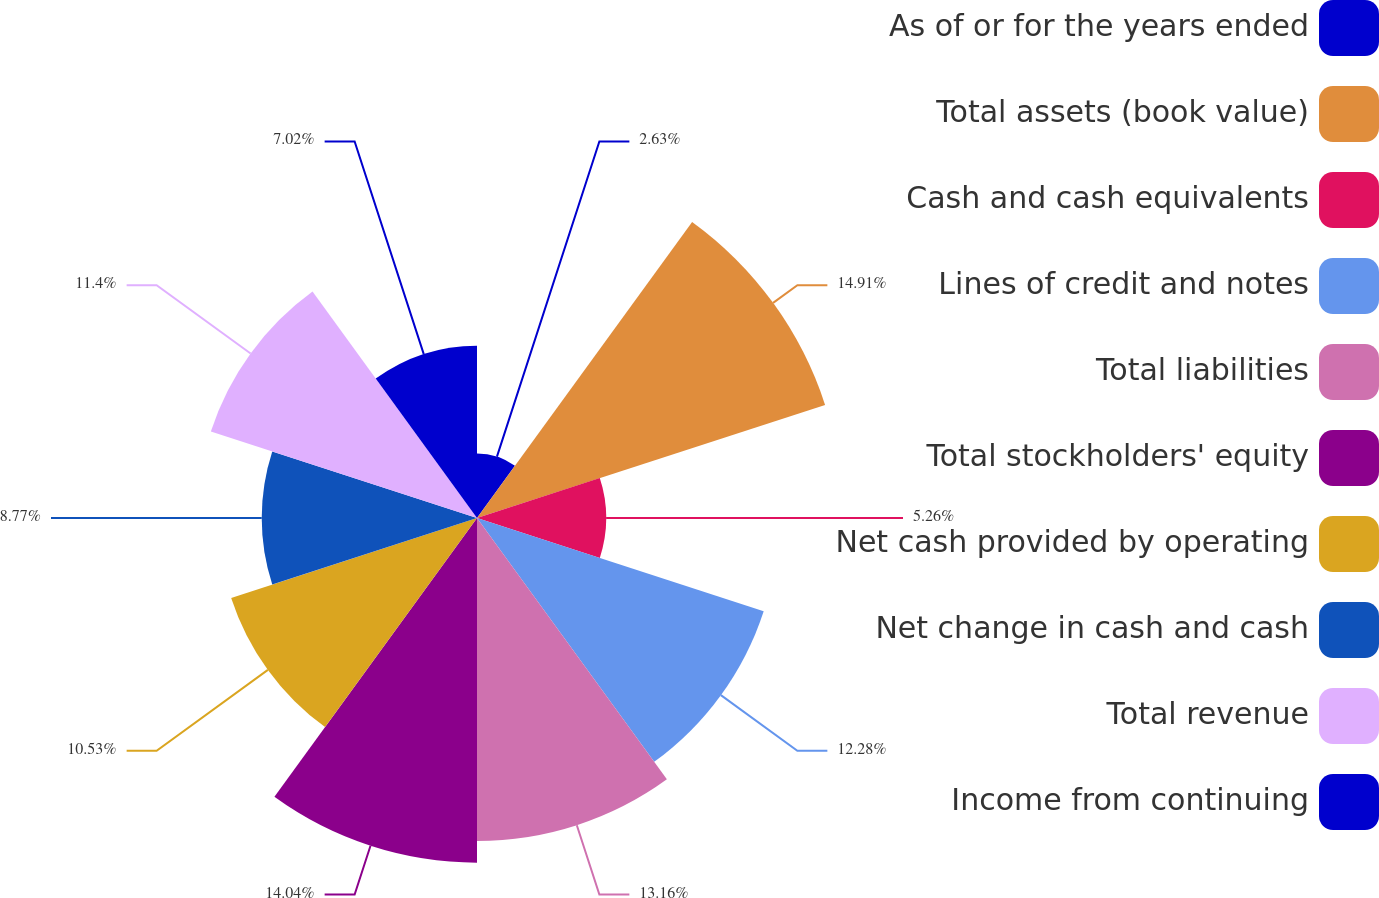Convert chart to OTSL. <chart><loc_0><loc_0><loc_500><loc_500><pie_chart><fcel>As of or for the years ended<fcel>Total assets (book value)<fcel>Cash and cash equivalents<fcel>Lines of credit and notes<fcel>Total liabilities<fcel>Total stockholders' equity<fcel>Net cash provided by operating<fcel>Net change in cash and cash<fcel>Total revenue<fcel>Income from continuing<nl><fcel>2.63%<fcel>14.91%<fcel>5.26%<fcel>12.28%<fcel>13.16%<fcel>14.04%<fcel>10.53%<fcel>8.77%<fcel>11.4%<fcel>7.02%<nl></chart> 